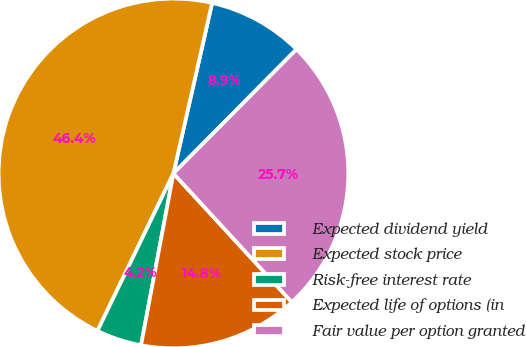Convert chart. <chart><loc_0><loc_0><loc_500><loc_500><pie_chart><fcel>Expected dividend yield<fcel>Expected stock price<fcel>Risk-free interest rate<fcel>Expected life of options (in<fcel>Fair value per option granted<nl><fcel>8.88%<fcel>46.39%<fcel>4.19%<fcel>14.8%<fcel>25.73%<nl></chart> 